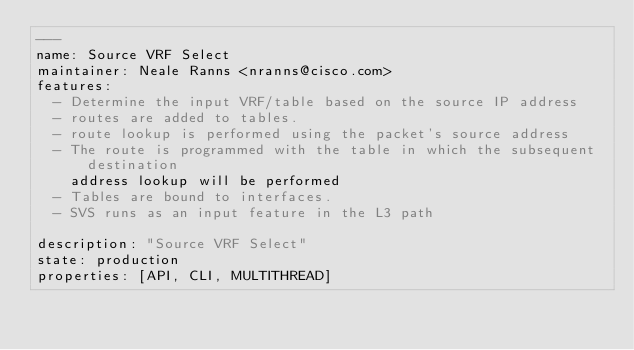Convert code to text. <code><loc_0><loc_0><loc_500><loc_500><_YAML_>---
name: Source VRF Select
maintainer: Neale Ranns <nranns@cisco.com>
features:
  - Determine the input VRF/table based on the source IP address
  - routes are added to tables.
  - route lookup is performed using the packet's source address
  - The route is programmed with the table in which the subsequent destination
    address lookup will be performed
  - Tables are bound to interfaces.
  - SVS runs as an input feature in the L3 path

description: "Source VRF Select"
state: production
properties: [API, CLI, MULTITHREAD]
</code> 